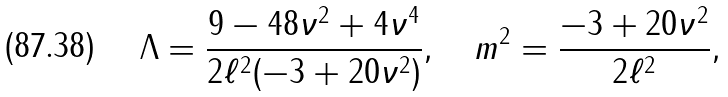<formula> <loc_0><loc_0><loc_500><loc_500>\Lambda = \frac { 9 - 4 8 \nu ^ { 2 } + 4 \nu ^ { 4 } } { 2 \ell ^ { 2 } ( - 3 + 2 0 \nu ^ { 2 } ) } , \quad m ^ { 2 } = \frac { - 3 + 2 0 \nu ^ { 2 } } { 2 \ell ^ { 2 } } ,</formula> 